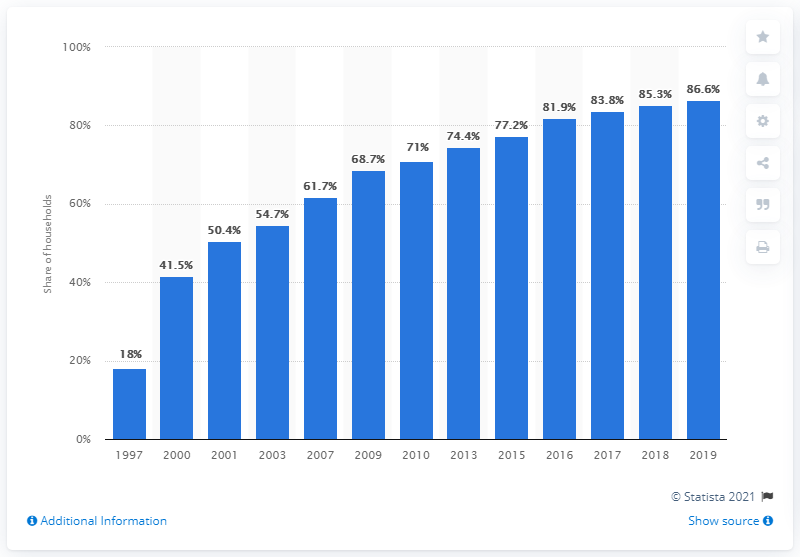Identify some key points in this picture. In 2019, 86.6% of U.S. households reported having at least one internet subscription. 